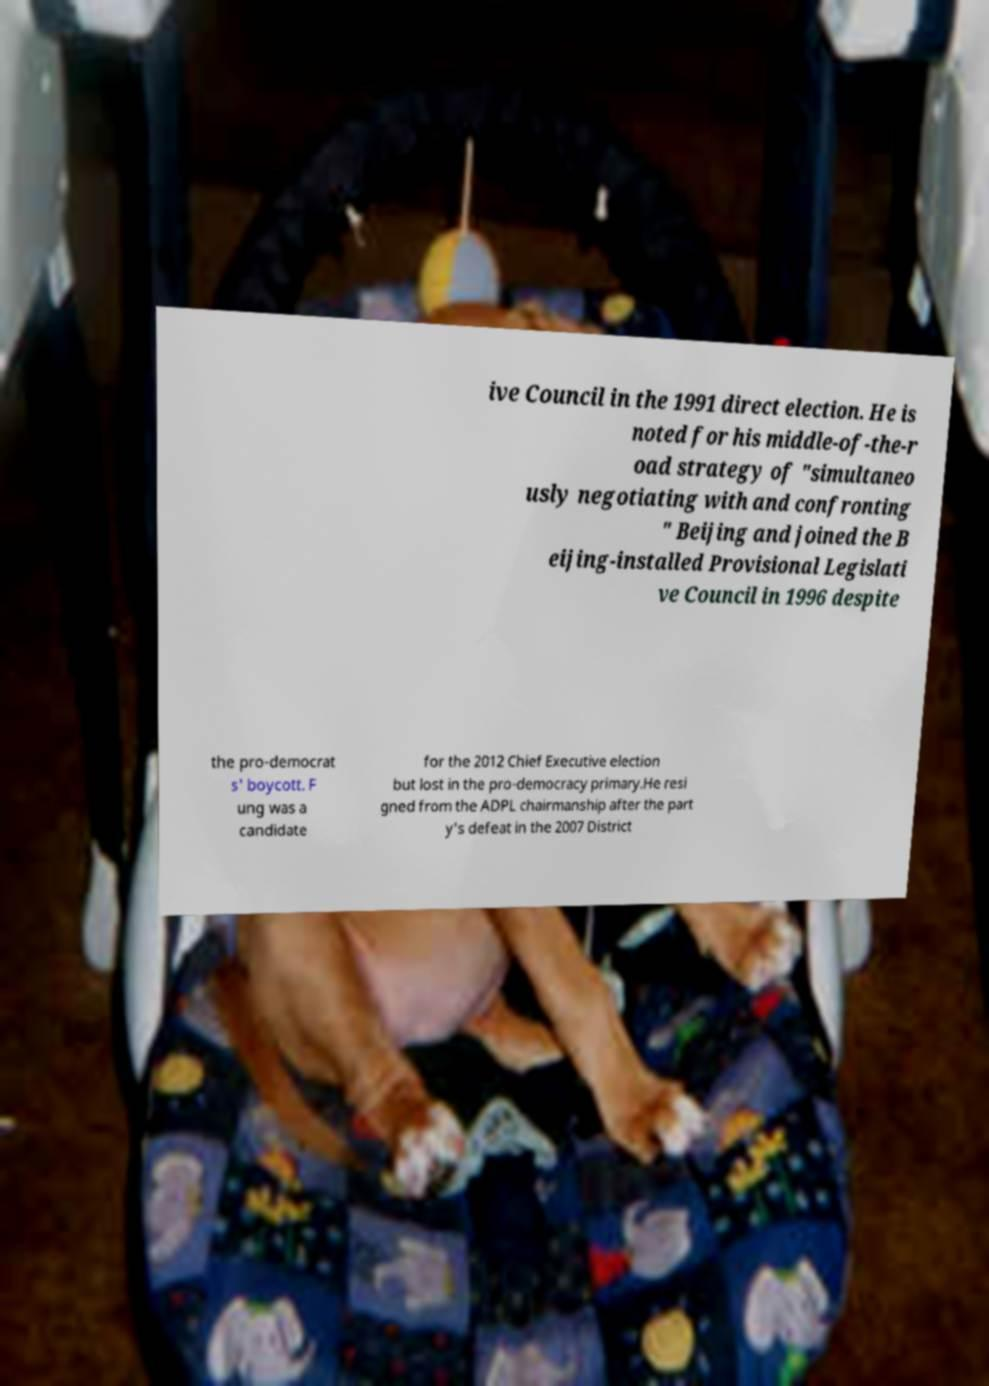Can you read and provide the text displayed in the image?This photo seems to have some interesting text. Can you extract and type it out for me? ive Council in the 1991 direct election. He is noted for his middle-of-the-r oad strategy of "simultaneo usly negotiating with and confronting " Beijing and joined the B eijing-installed Provisional Legislati ve Council in 1996 despite the pro-democrat s' boycott. F ung was a candidate for the 2012 Chief Executive election but lost in the pro-democracy primary.He resi gned from the ADPL chairmanship after the part y's defeat in the 2007 District 